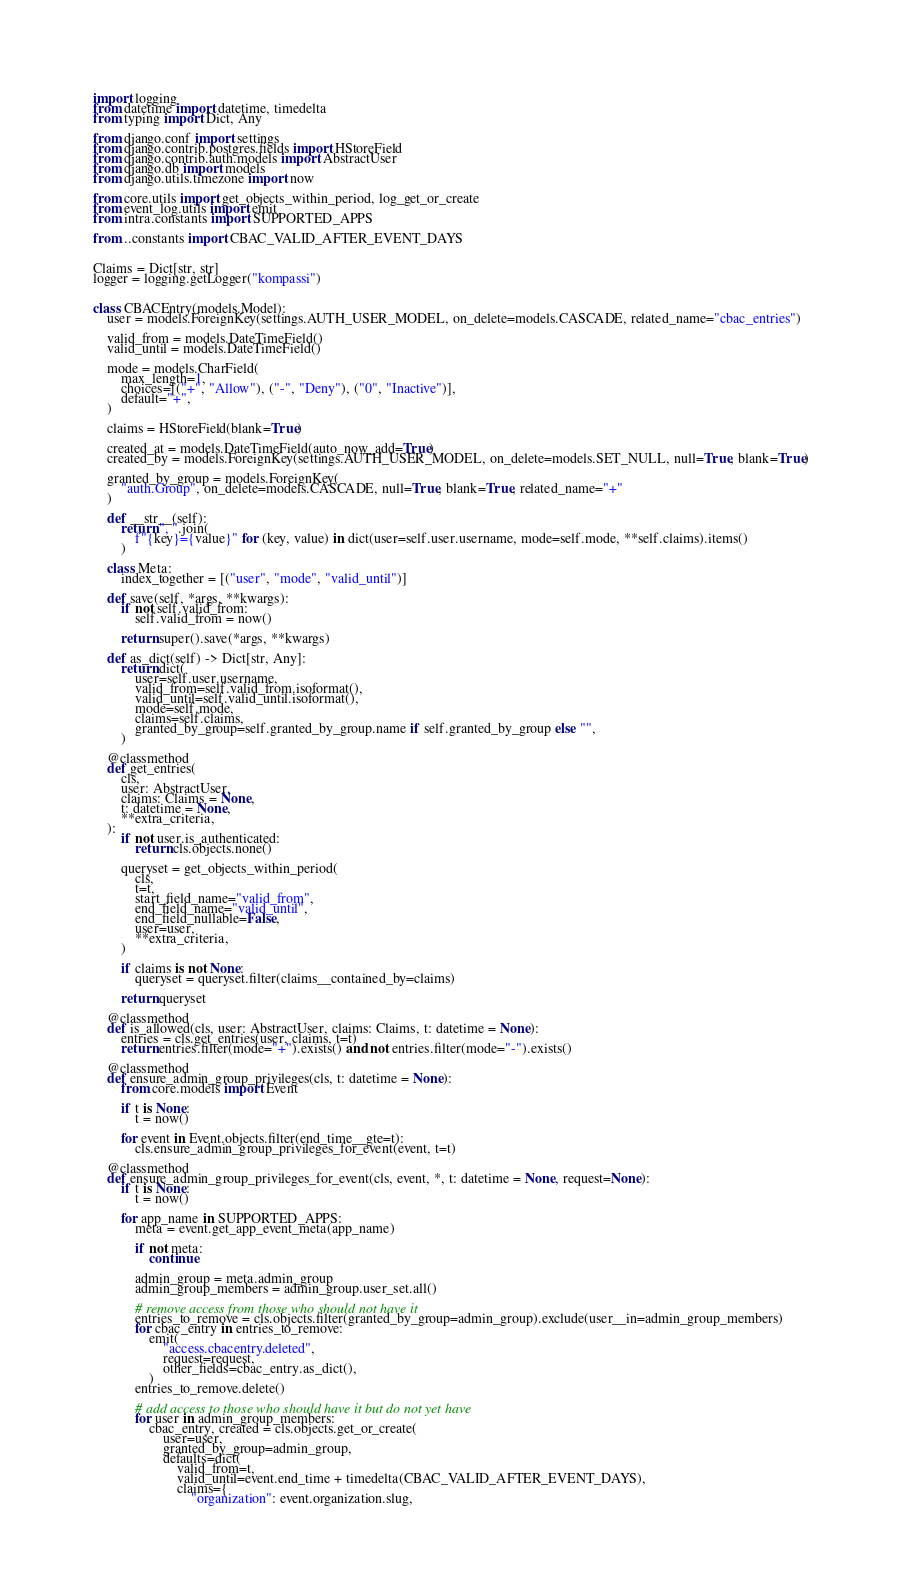<code> <loc_0><loc_0><loc_500><loc_500><_Python_>import logging
from datetime import datetime, timedelta
from typing import Dict, Any

from django.conf import settings
from django.contrib.postgres.fields import HStoreField
from django.contrib.auth.models import AbstractUser
from django.db import models
from django.utils.timezone import now

from core.utils import get_objects_within_period, log_get_or_create
from event_log.utils import emit
from intra.constants import SUPPORTED_APPS

from ..constants import CBAC_VALID_AFTER_EVENT_DAYS


Claims = Dict[str, str]
logger = logging.getLogger("kompassi")


class CBACEntry(models.Model):
    user = models.ForeignKey(settings.AUTH_USER_MODEL, on_delete=models.CASCADE, related_name="cbac_entries")

    valid_from = models.DateTimeField()
    valid_until = models.DateTimeField()

    mode = models.CharField(
        max_length=1,
        choices=[("+", "Allow"), ("-", "Deny"), ("0", "Inactive")],
        default="+",
    )

    claims = HStoreField(blank=True)

    created_at = models.DateTimeField(auto_now_add=True)
    created_by = models.ForeignKey(settings.AUTH_USER_MODEL, on_delete=models.SET_NULL, null=True, blank=True)

    granted_by_group = models.ForeignKey(
        "auth.Group", on_delete=models.CASCADE, null=True, blank=True, related_name="+"
    )

    def __str__(self):
        return ", ".join(
            f"{key}={value}" for (key, value) in dict(user=self.user.username, mode=self.mode, **self.claims).items()
        )

    class Meta:
        index_together = [("user", "mode", "valid_until")]

    def save(self, *args, **kwargs):
        if not self.valid_from:
            self.valid_from = now()

        return super().save(*args, **kwargs)

    def as_dict(self) -> Dict[str, Any]:
        return dict(
            user=self.user.username,
            valid_from=self.valid_from.isoformat(),
            valid_until=self.valid_until.isoformat(),
            mode=self.mode,
            claims=self.claims,
            granted_by_group=self.granted_by_group.name if self.granted_by_group else "",
        )

    @classmethod
    def get_entries(
        cls,
        user: AbstractUser,
        claims: Claims = None,
        t: datetime = None,
        **extra_criteria,
    ):
        if not user.is_authenticated:
            return cls.objects.none()

        queryset = get_objects_within_period(
            cls,
            t=t,
            start_field_name="valid_from",
            end_field_name="valid_until",
            end_field_nullable=False,
            user=user,
            **extra_criteria,
        )

        if claims is not None:
            queryset = queryset.filter(claims__contained_by=claims)

        return queryset

    @classmethod
    def is_allowed(cls, user: AbstractUser, claims: Claims, t: datetime = None):
        entries = cls.get_entries(user, claims, t=t)
        return entries.filter(mode="+").exists() and not entries.filter(mode="-").exists()

    @classmethod
    def ensure_admin_group_privileges(cls, t: datetime = None):
        from core.models import Event

        if t is None:
            t = now()

        for event in Event.objects.filter(end_time__gte=t):
            cls.ensure_admin_group_privileges_for_event(event, t=t)

    @classmethod
    def ensure_admin_group_privileges_for_event(cls, event, *, t: datetime = None, request=None):
        if t is None:
            t = now()

        for app_name in SUPPORTED_APPS:
            meta = event.get_app_event_meta(app_name)

            if not meta:
                continue

            admin_group = meta.admin_group
            admin_group_members = admin_group.user_set.all()

            # remove access from those who should not have it
            entries_to_remove = cls.objects.filter(granted_by_group=admin_group).exclude(user__in=admin_group_members)
            for cbac_entry in entries_to_remove:
                emit(
                    "access.cbacentry.deleted",
                    request=request,
                    other_fields=cbac_entry.as_dict(),
                )
            entries_to_remove.delete()

            # add access to those who should have it but do not yet have
            for user in admin_group_members:
                cbac_entry, created = cls.objects.get_or_create(
                    user=user,
                    granted_by_group=admin_group,
                    defaults=dict(
                        valid_from=t,
                        valid_until=event.end_time + timedelta(CBAC_VALID_AFTER_EVENT_DAYS),
                        claims={
                            "organization": event.organization.slug,</code> 